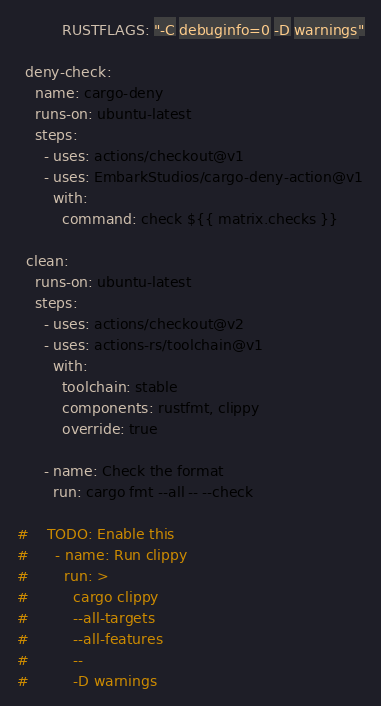<code> <loc_0><loc_0><loc_500><loc_500><_YAML_>          RUSTFLAGS: "-C debuginfo=0 -D warnings"

  deny-check:
    name: cargo-deny
    runs-on: ubuntu-latest
    steps:
      - uses: actions/checkout@v1
      - uses: EmbarkStudios/cargo-deny-action@v1
        with:
          command: check ${{ matrix.checks }}

  clean:
    runs-on: ubuntu-latest
    steps:
      - uses: actions/checkout@v2
      - uses: actions-rs/toolchain@v1
        with:
          toolchain: stable
          components: rustfmt, clippy
          override: true

      - name: Check the format
        run: cargo fmt --all -- --check

#    TODO: Enable this
#      - name: Run clippy
#        run: >
#          cargo clippy
#          --all-targets
#          --all-features
#          --
#          -D warnings
</code> 